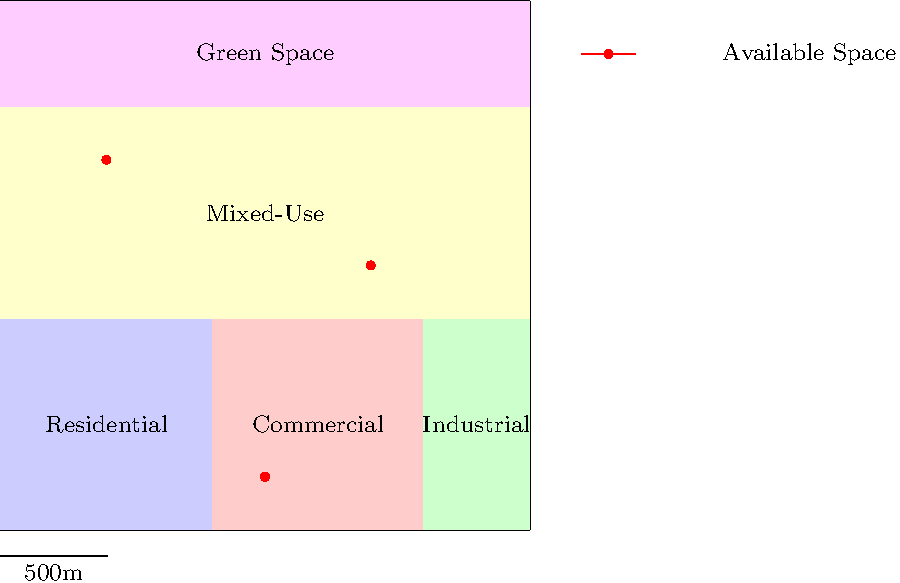Based on the city zoning map provided, which available commercial space would be most suitable for opening a local brewery, considering both zoning regulations and potential foot traffic? To determine the most suitable location for a local brewery, we need to consider several factors:

1. Zoning regulations: A brewery typically falls under commercial or mixed-use zoning.

2. Available spaces: The map shows three available spaces marked with red dots.

3. Zoning of available spaces:
   - Space 1: Located in the Commercial zone (red area)
   - Space 2: Located in the Mixed-Use zone (yellow area)
   - Space 3: Located in the Mixed-Use zone (yellow area)

4. Foot traffic potential:
   - Space 1: Near residential area, but isolated from other zones
   - Space 2: Central location, adjacent to all other zones
   - Space 3: Close to residential and green space, but farther from commercial area

5. Suitability analysis:
   - Space 1: Allowed by zoning, but may have less foot traffic
   - Space 2: Allowed by zoning, central location with high foot traffic potential
   - Space 3: Allowed by zoning, good proximity to residential areas, but less central

Considering these factors, Space 2 in the Mixed-Use zone offers the best combination of suitable zoning and potential foot traffic due to its central location and proximity to all other zones.
Answer: Space 2 in the Mixed-Use zone 